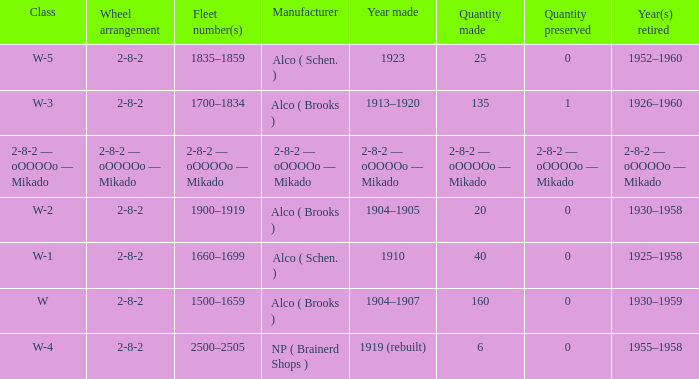Identify the class of locomotive that features a 2-8-2 wheel arrangement and has 25 units built. W-5. 